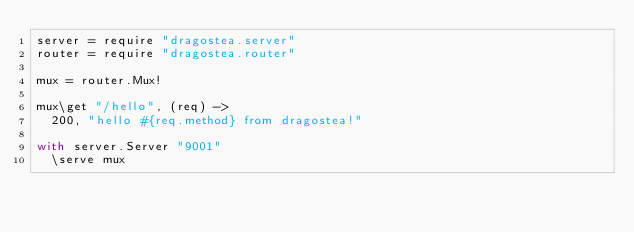Convert code to text. <code><loc_0><loc_0><loc_500><loc_500><_MoonScript_>server = require "dragostea.server"
router = require "dragostea.router"

mux = router.Mux!

mux\get "/hello", (req) ->
  200, "hello #{req.method} from dragostea!"

with server.Server "9001"
  \serve mux
</code> 